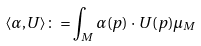<formula> <loc_0><loc_0><loc_500><loc_500>\langle \alpha , U \rangle \colon = \int _ { M } \alpha ( p ) \, \cdot \, U ( p ) \mu _ { M }</formula> 